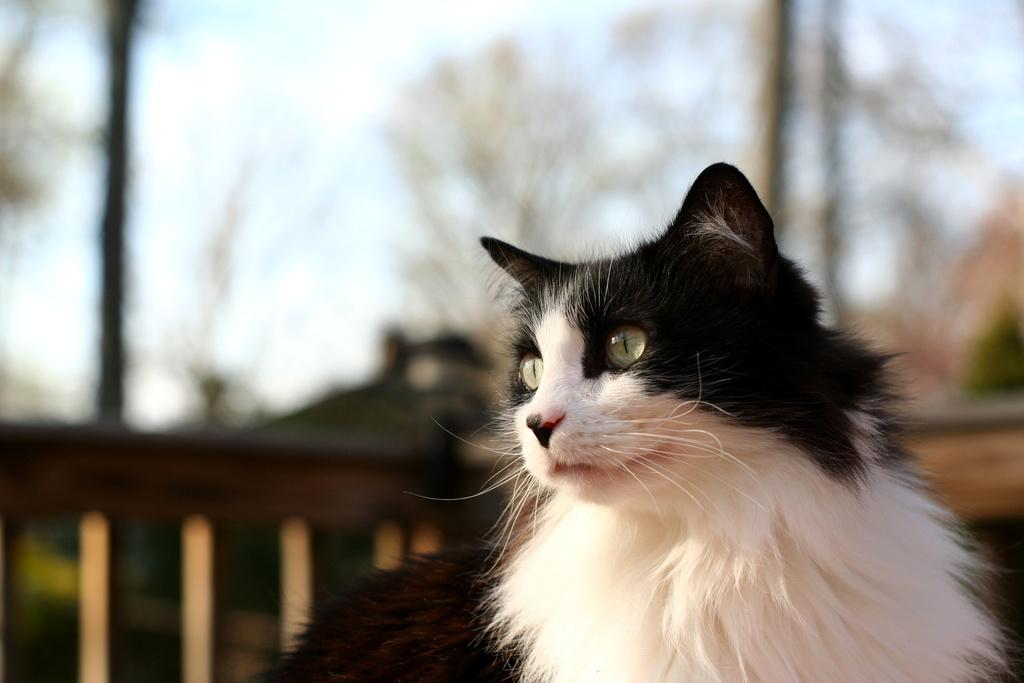What type of animal is in the image? There is a cat in the image. Can you describe the appearance of the cat? The cat is black and white. What can be observed about the background of the image? The background of the image is blurred. What type of seed is the cat planting in the image? There is no seed or planting activity present in the image; it features a black and white cat with a blurred background. 